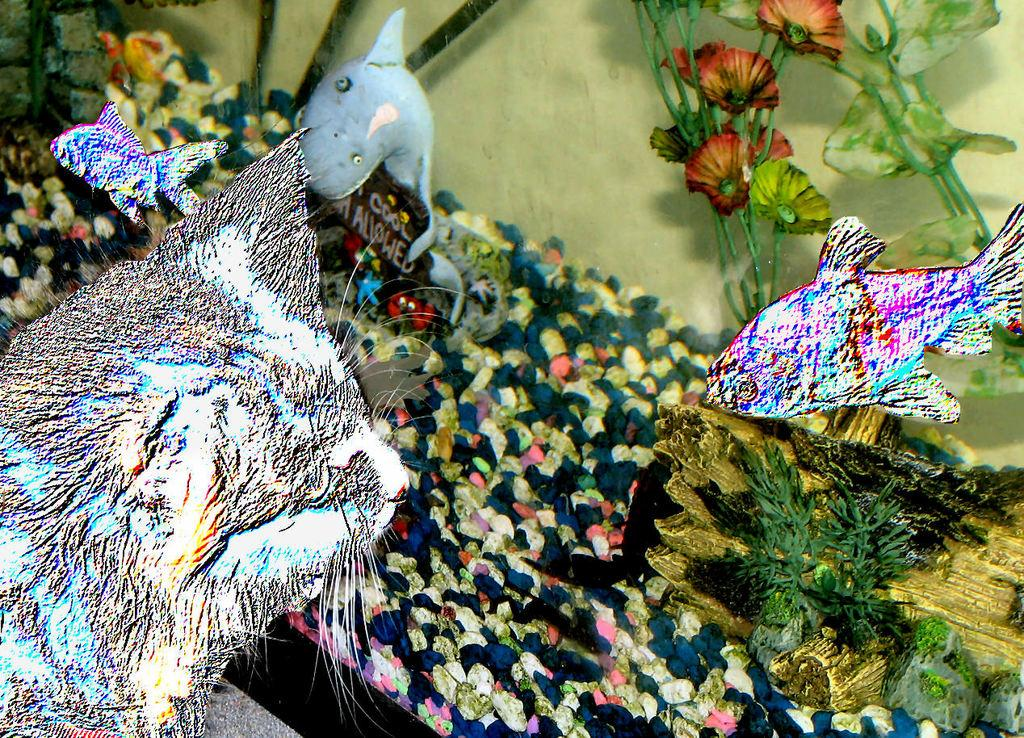What is the main feature of the image? There is an aquarium in the image. What can be found inside the aquarium? There are fishes, stones, and artificial plants in the aquarium. Can you describe the surroundings of the aquarium? There appears to be a cat on the left side of the image. What type of plantation can be seen in the background of the image? There is no plantation present in the image; it features an aquarium with fishes, stones, and artificial plants. Can you tell me how many trains are visible in the image? There are no trains visible in the image. 